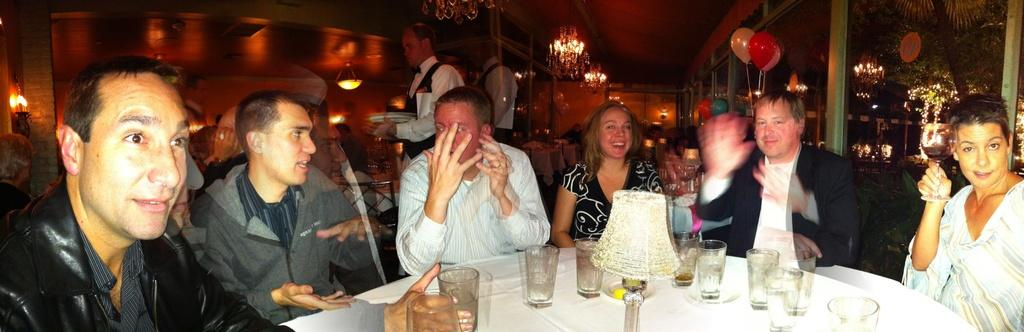What are the people in the image doing? The people in the image are sitting on chairs. What objects can be seen on the table? There are glasses and a light on the table. What decorative element is present on the door in the background? Balloons are visible on the door in the background. What type of liquid is being served in the glasses on the table? There is no information about the contents of the glasses in the image, so we cannot determine if there is any liquid present. 